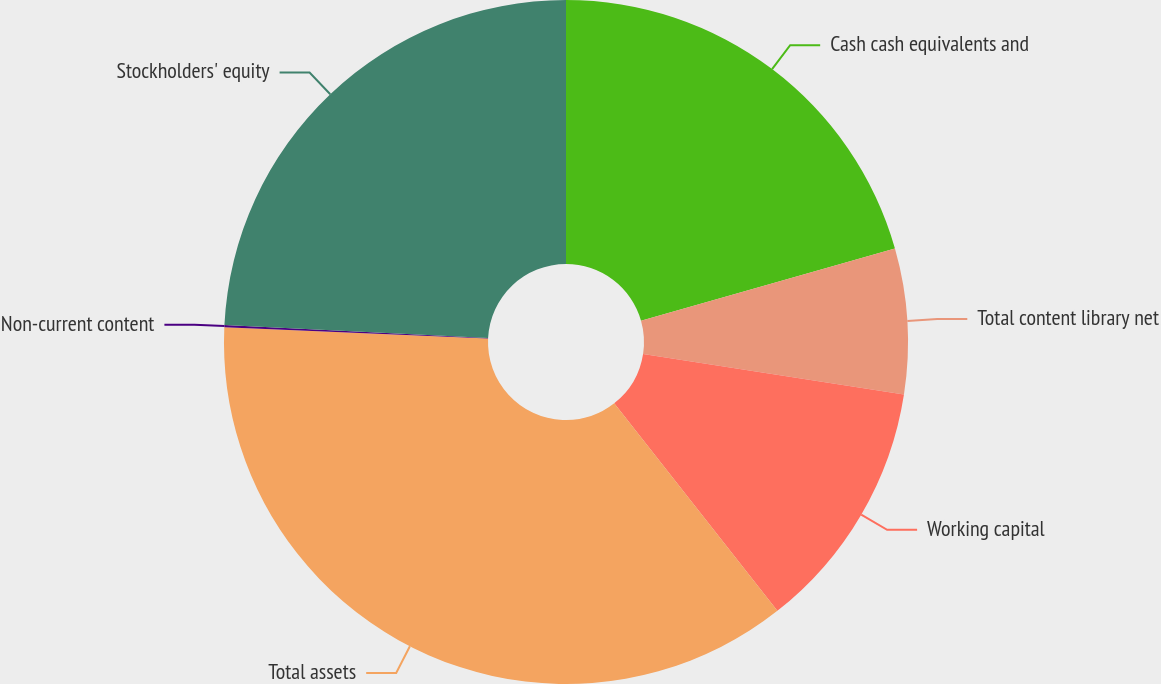<chart> <loc_0><loc_0><loc_500><loc_500><pie_chart><fcel>Cash cash equivalents and<fcel>Total content library net<fcel>Working capital<fcel>Total assets<fcel>Non-current content<fcel>Stockholders' equity<nl><fcel>20.59%<fcel>6.86%<fcel>11.95%<fcel>36.3%<fcel>0.1%<fcel>24.21%<nl></chart> 